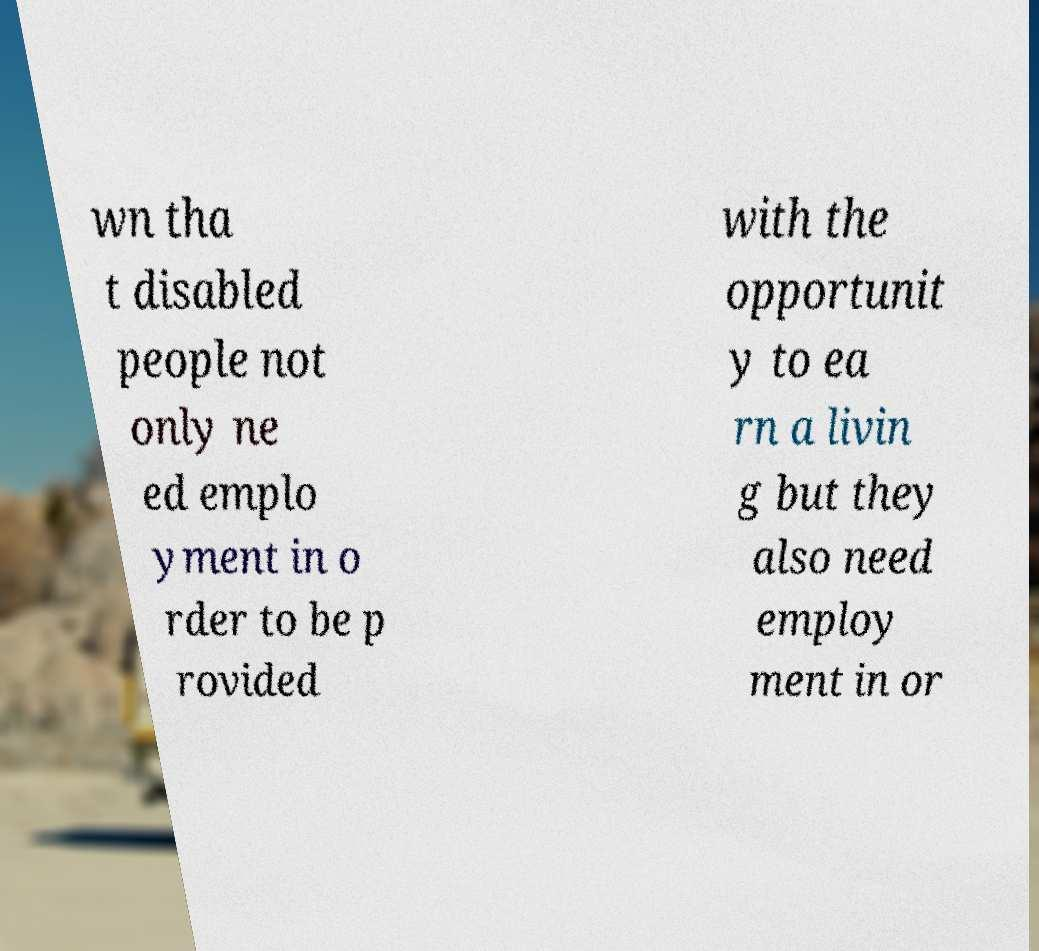Please read and relay the text visible in this image. What does it say? wn tha t disabled people not only ne ed emplo yment in o rder to be p rovided with the opportunit y to ea rn a livin g but they also need employ ment in or 